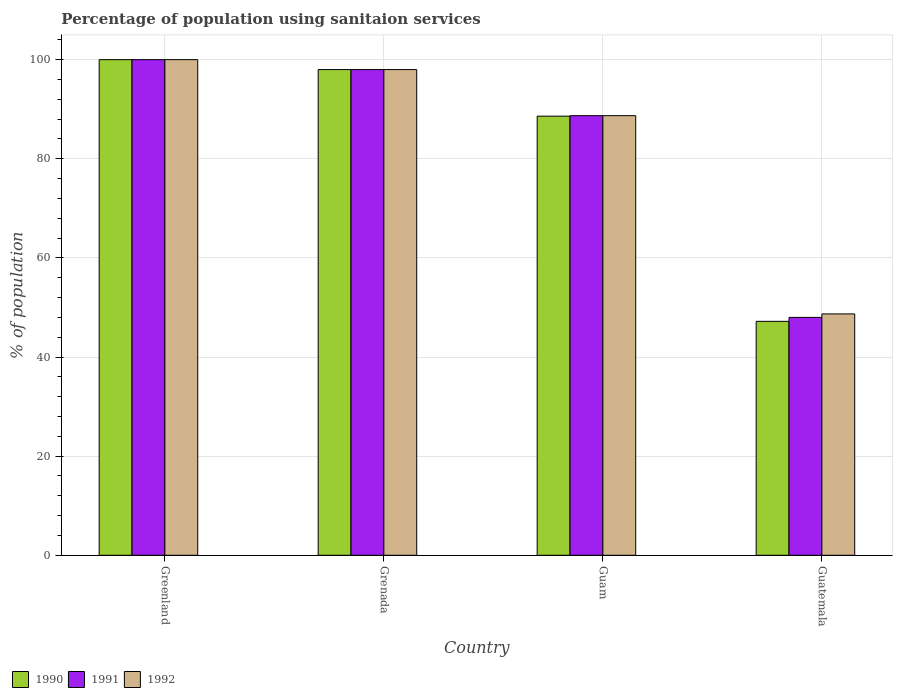How many bars are there on the 4th tick from the left?
Keep it short and to the point. 3. How many bars are there on the 1st tick from the right?
Offer a terse response. 3. What is the label of the 2nd group of bars from the left?
Your answer should be compact. Grenada. In how many cases, is the number of bars for a given country not equal to the number of legend labels?
Your answer should be compact. 0. Across all countries, what is the maximum percentage of population using sanitaion services in 1992?
Make the answer very short. 100. Across all countries, what is the minimum percentage of population using sanitaion services in 1991?
Keep it short and to the point. 48. In which country was the percentage of population using sanitaion services in 1991 maximum?
Keep it short and to the point. Greenland. In which country was the percentage of population using sanitaion services in 1990 minimum?
Your answer should be compact. Guatemala. What is the total percentage of population using sanitaion services in 1992 in the graph?
Your answer should be compact. 335.4. What is the average percentage of population using sanitaion services in 1991 per country?
Keep it short and to the point. 83.67. In how many countries, is the percentage of population using sanitaion services in 1990 greater than 20 %?
Give a very brief answer. 4. What is the ratio of the percentage of population using sanitaion services in 1990 in Greenland to that in Grenada?
Offer a very short reply. 1.02. Is the difference between the percentage of population using sanitaion services in 1990 in Guam and Guatemala greater than the difference between the percentage of population using sanitaion services in 1992 in Guam and Guatemala?
Provide a succinct answer. Yes. What is the difference between the highest and the second highest percentage of population using sanitaion services in 1990?
Provide a short and direct response. -9.4. What is the difference between the highest and the lowest percentage of population using sanitaion services in 1990?
Provide a succinct answer. 52.8. What does the 3rd bar from the left in Guatemala represents?
Keep it short and to the point. 1992. How many bars are there?
Make the answer very short. 12. How many countries are there in the graph?
Your answer should be very brief. 4. What is the difference between two consecutive major ticks on the Y-axis?
Give a very brief answer. 20. Are the values on the major ticks of Y-axis written in scientific E-notation?
Your response must be concise. No. Does the graph contain grids?
Keep it short and to the point. Yes. What is the title of the graph?
Provide a short and direct response. Percentage of population using sanitaion services. Does "2006" appear as one of the legend labels in the graph?
Provide a succinct answer. No. What is the label or title of the Y-axis?
Ensure brevity in your answer.  % of population. What is the % of population of 1990 in Greenland?
Provide a succinct answer. 100. What is the % of population in 1992 in Greenland?
Give a very brief answer. 100. What is the % of population in 1991 in Grenada?
Provide a succinct answer. 98. What is the % of population of 1990 in Guam?
Make the answer very short. 88.6. What is the % of population in 1991 in Guam?
Keep it short and to the point. 88.7. What is the % of population in 1992 in Guam?
Your answer should be compact. 88.7. What is the % of population of 1990 in Guatemala?
Your answer should be very brief. 47.2. What is the % of population of 1991 in Guatemala?
Provide a succinct answer. 48. What is the % of population in 1992 in Guatemala?
Your answer should be very brief. 48.7. Across all countries, what is the maximum % of population of 1990?
Offer a terse response. 100. Across all countries, what is the maximum % of population in 1991?
Offer a very short reply. 100. Across all countries, what is the maximum % of population in 1992?
Provide a short and direct response. 100. Across all countries, what is the minimum % of population of 1990?
Give a very brief answer. 47.2. Across all countries, what is the minimum % of population of 1992?
Offer a very short reply. 48.7. What is the total % of population of 1990 in the graph?
Offer a very short reply. 333.8. What is the total % of population of 1991 in the graph?
Offer a terse response. 334.7. What is the total % of population in 1992 in the graph?
Offer a very short reply. 335.4. What is the difference between the % of population of 1991 in Greenland and that in Grenada?
Your answer should be very brief. 2. What is the difference between the % of population of 1990 in Greenland and that in Guam?
Ensure brevity in your answer.  11.4. What is the difference between the % of population in 1990 in Greenland and that in Guatemala?
Provide a short and direct response. 52.8. What is the difference between the % of population in 1991 in Greenland and that in Guatemala?
Your answer should be very brief. 52. What is the difference between the % of population in 1992 in Greenland and that in Guatemala?
Provide a succinct answer. 51.3. What is the difference between the % of population of 1992 in Grenada and that in Guam?
Your response must be concise. 9.3. What is the difference between the % of population of 1990 in Grenada and that in Guatemala?
Offer a terse response. 50.8. What is the difference between the % of population in 1991 in Grenada and that in Guatemala?
Keep it short and to the point. 50. What is the difference between the % of population in 1992 in Grenada and that in Guatemala?
Give a very brief answer. 49.3. What is the difference between the % of population of 1990 in Guam and that in Guatemala?
Give a very brief answer. 41.4. What is the difference between the % of population in 1991 in Guam and that in Guatemala?
Your answer should be compact. 40.7. What is the difference between the % of population in 1992 in Guam and that in Guatemala?
Keep it short and to the point. 40. What is the difference between the % of population in 1990 in Greenland and the % of population in 1991 in Grenada?
Keep it short and to the point. 2. What is the difference between the % of population of 1991 in Greenland and the % of population of 1992 in Grenada?
Your answer should be very brief. 2. What is the difference between the % of population in 1991 in Greenland and the % of population in 1992 in Guam?
Your response must be concise. 11.3. What is the difference between the % of population of 1990 in Greenland and the % of population of 1992 in Guatemala?
Make the answer very short. 51.3. What is the difference between the % of population in 1991 in Greenland and the % of population in 1992 in Guatemala?
Give a very brief answer. 51.3. What is the difference between the % of population of 1991 in Grenada and the % of population of 1992 in Guam?
Provide a short and direct response. 9.3. What is the difference between the % of population of 1990 in Grenada and the % of population of 1991 in Guatemala?
Your response must be concise. 50. What is the difference between the % of population of 1990 in Grenada and the % of population of 1992 in Guatemala?
Offer a terse response. 49.3. What is the difference between the % of population in 1991 in Grenada and the % of population in 1992 in Guatemala?
Keep it short and to the point. 49.3. What is the difference between the % of population in 1990 in Guam and the % of population in 1991 in Guatemala?
Provide a short and direct response. 40.6. What is the difference between the % of population in 1990 in Guam and the % of population in 1992 in Guatemala?
Your answer should be very brief. 39.9. What is the average % of population of 1990 per country?
Provide a short and direct response. 83.45. What is the average % of population in 1991 per country?
Make the answer very short. 83.67. What is the average % of population in 1992 per country?
Keep it short and to the point. 83.85. What is the difference between the % of population in 1990 and % of population in 1992 in Greenland?
Your answer should be very brief. 0. What is the difference between the % of population of 1990 and % of population of 1991 in Grenada?
Your answer should be very brief. 0. What is the difference between the % of population in 1990 and % of population in 1992 in Grenada?
Give a very brief answer. 0. What is the difference between the % of population in 1991 and % of population in 1992 in Grenada?
Provide a succinct answer. 0. What is the difference between the % of population of 1991 and % of population of 1992 in Guatemala?
Your answer should be compact. -0.7. What is the ratio of the % of population in 1990 in Greenland to that in Grenada?
Your response must be concise. 1.02. What is the ratio of the % of population of 1991 in Greenland to that in Grenada?
Provide a succinct answer. 1.02. What is the ratio of the % of population of 1992 in Greenland to that in Grenada?
Give a very brief answer. 1.02. What is the ratio of the % of population in 1990 in Greenland to that in Guam?
Your answer should be very brief. 1.13. What is the ratio of the % of population in 1991 in Greenland to that in Guam?
Your answer should be compact. 1.13. What is the ratio of the % of population in 1992 in Greenland to that in Guam?
Provide a short and direct response. 1.13. What is the ratio of the % of population of 1990 in Greenland to that in Guatemala?
Make the answer very short. 2.12. What is the ratio of the % of population of 1991 in Greenland to that in Guatemala?
Give a very brief answer. 2.08. What is the ratio of the % of population of 1992 in Greenland to that in Guatemala?
Offer a terse response. 2.05. What is the ratio of the % of population in 1990 in Grenada to that in Guam?
Provide a succinct answer. 1.11. What is the ratio of the % of population in 1991 in Grenada to that in Guam?
Your answer should be very brief. 1.1. What is the ratio of the % of population of 1992 in Grenada to that in Guam?
Your answer should be compact. 1.1. What is the ratio of the % of population of 1990 in Grenada to that in Guatemala?
Ensure brevity in your answer.  2.08. What is the ratio of the % of population of 1991 in Grenada to that in Guatemala?
Ensure brevity in your answer.  2.04. What is the ratio of the % of population in 1992 in Grenada to that in Guatemala?
Provide a succinct answer. 2.01. What is the ratio of the % of population of 1990 in Guam to that in Guatemala?
Your answer should be very brief. 1.88. What is the ratio of the % of population in 1991 in Guam to that in Guatemala?
Make the answer very short. 1.85. What is the ratio of the % of population in 1992 in Guam to that in Guatemala?
Offer a terse response. 1.82. What is the difference between the highest and the second highest % of population in 1990?
Make the answer very short. 2. What is the difference between the highest and the lowest % of population of 1990?
Your answer should be compact. 52.8. What is the difference between the highest and the lowest % of population of 1992?
Make the answer very short. 51.3. 